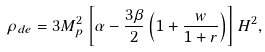<formula> <loc_0><loc_0><loc_500><loc_500>\rho _ { d e } = 3 M _ { p } ^ { 2 } \left [ \alpha - \frac { 3 \beta } { 2 } \left ( 1 + \frac { w } { 1 + r } \right ) \right ] H ^ { 2 } ,</formula> 